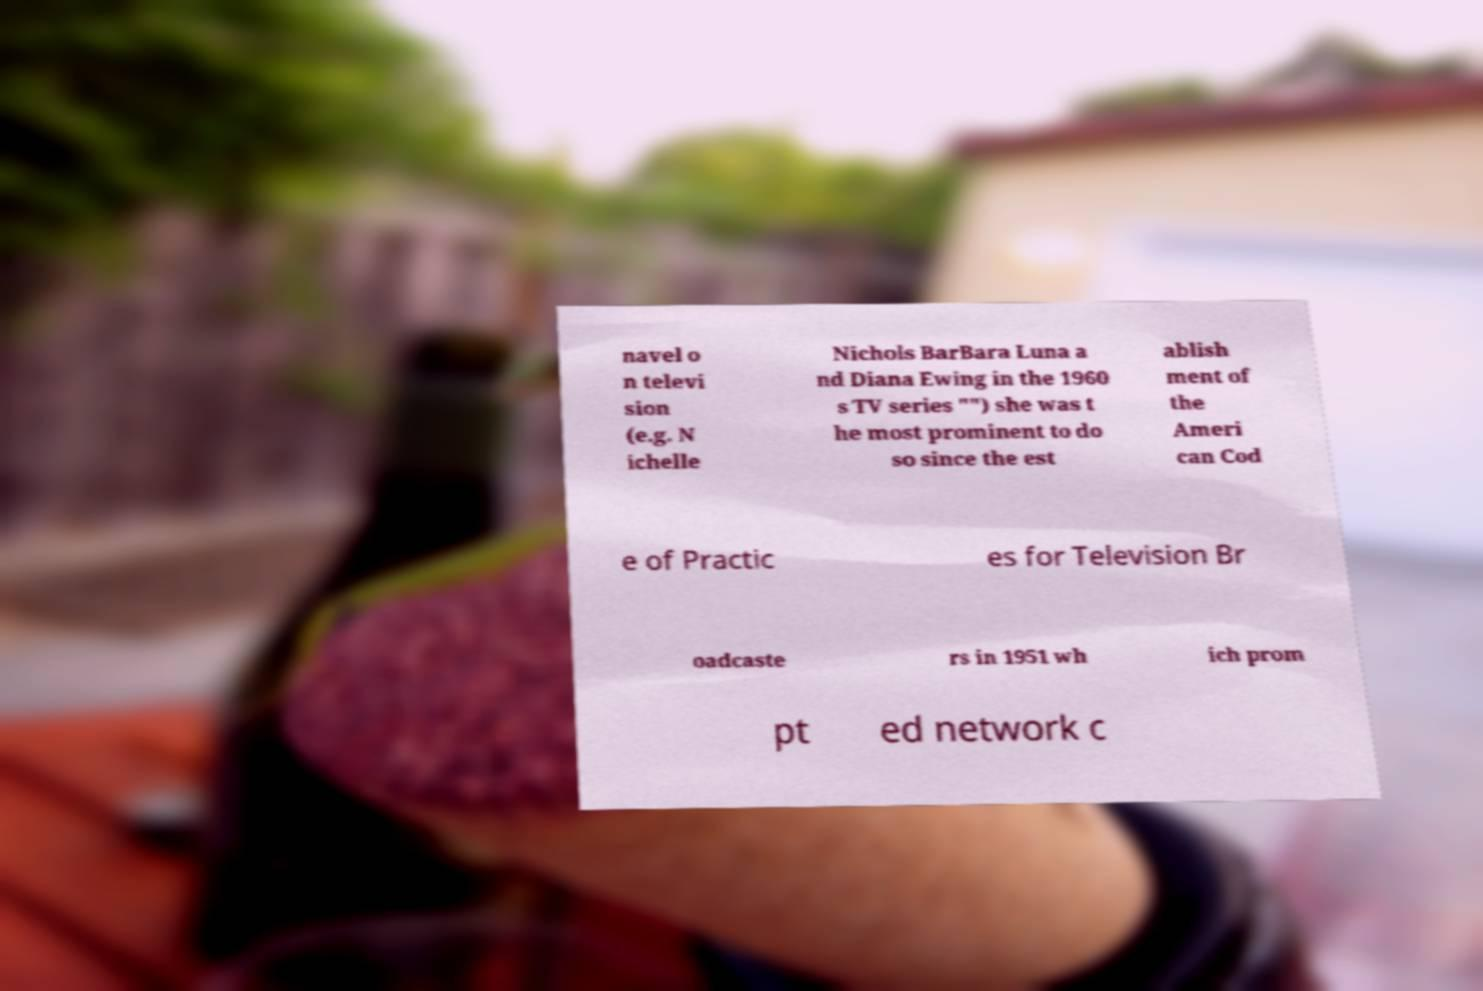What messages or text are displayed in this image? I need them in a readable, typed format. navel o n televi sion (e.g. N ichelle Nichols BarBara Luna a nd Diana Ewing in the 1960 s TV series "") she was t he most prominent to do so since the est ablish ment of the Ameri can Cod e of Practic es for Television Br oadcaste rs in 1951 wh ich prom pt ed network c 